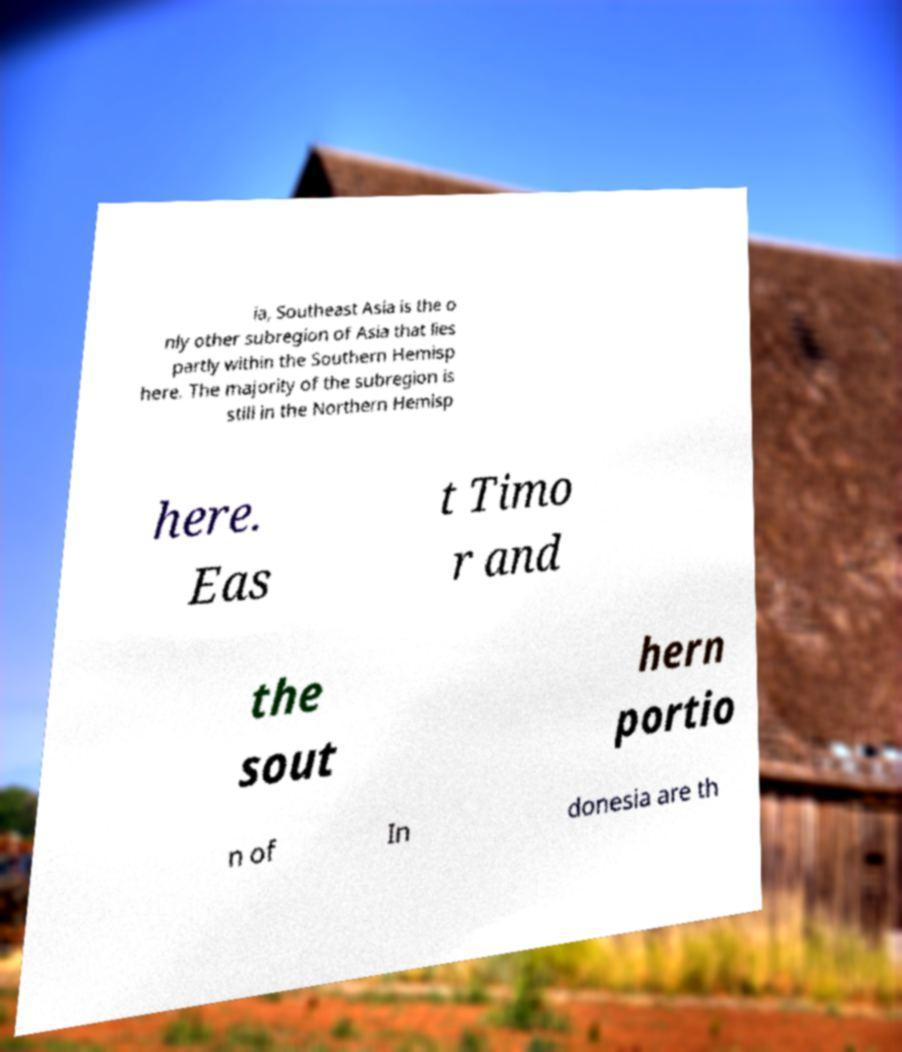There's text embedded in this image that I need extracted. Can you transcribe it verbatim? ia, Southeast Asia is the o nly other subregion of Asia that lies partly within the Southern Hemisp here. The majority of the subregion is still in the Northern Hemisp here. Eas t Timo r and the sout hern portio n of In donesia are th 